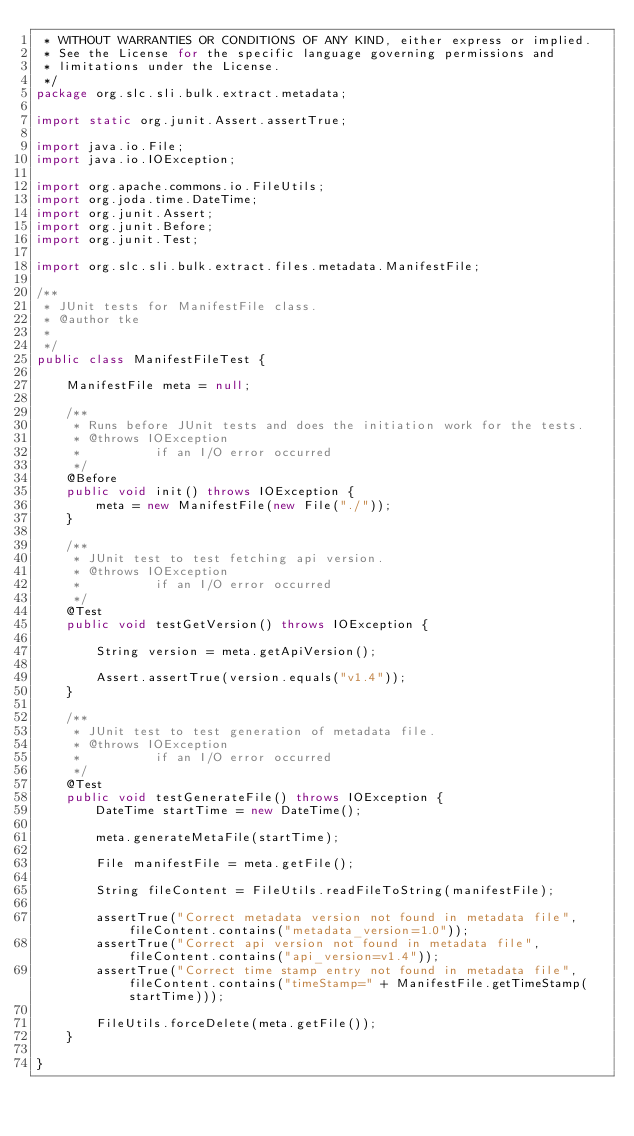<code> <loc_0><loc_0><loc_500><loc_500><_Java_> * WITHOUT WARRANTIES OR CONDITIONS OF ANY KIND, either express or implied.
 * See the License for the specific language governing permissions and
 * limitations under the License.
 */
package org.slc.sli.bulk.extract.metadata;

import static org.junit.Assert.assertTrue;

import java.io.File;
import java.io.IOException;

import org.apache.commons.io.FileUtils;
import org.joda.time.DateTime;
import org.junit.Assert;
import org.junit.Before;
import org.junit.Test;

import org.slc.sli.bulk.extract.files.metadata.ManifestFile;

/**
 * JUnit tests for ManifestFile class.
 * @author tke
 *
 */
public class ManifestFileTest {

    ManifestFile meta = null;

    /**
     * Runs before JUnit tests and does the initiation work for the tests.
     * @throws IOException
     *          if an I/O error occurred
     */
    @Before
    public void init() throws IOException {
        meta = new ManifestFile(new File("./"));
    }

    /**
     * JUnit test to test fetching api version.
     * @throws IOException
     *          if an I/O error occurred
     */
    @Test
    public void testGetVersion() throws IOException {

        String version = meta.getApiVersion();

        Assert.assertTrue(version.equals("v1.4"));
    }

    /**
     * JUnit test to test generation of metadata file.
     * @throws IOException
     *          if an I/O error occurred
     */
    @Test
    public void testGenerateFile() throws IOException {
        DateTime startTime = new DateTime();

        meta.generateMetaFile(startTime);

        File manifestFile = meta.getFile();

        String fileContent = FileUtils.readFileToString(manifestFile);

        assertTrue("Correct metadata version not found in metadata file", fileContent.contains("metadata_version=1.0"));
        assertTrue("Correct api version not found in metadata file", fileContent.contains("api_version=v1.4"));
        assertTrue("Correct time stamp entry not found in metadata file", fileContent.contains("timeStamp=" + ManifestFile.getTimeStamp(startTime)));

        FileUtils.forceDelete(meta.getFile());
    }

}
</code> 